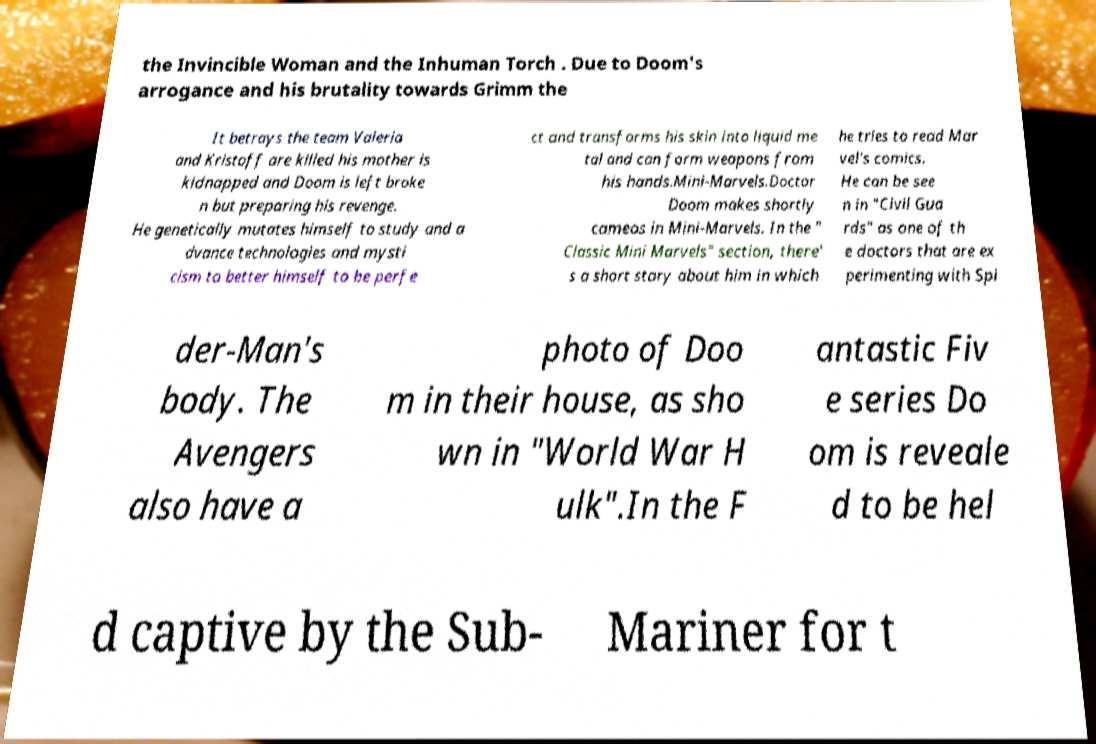Can you read and provide the text displayed in the image?This photo seems to have some interesting text. Can you extract and type it out for me? the Invincible Woman and the Inhuman Torch . Due to Doom's arrogance and his brutality towards Grimm the It betrays the team Valeria and Kristoff are killed his mother is kidnapped and Doom is left broke n but preparing his revenge. He genetically mutates himself to study and a dvance technologies and mysti cism to better himself to be perfe ct and transforms his skin into liquid me tal and can form weapons from his hands.Mini-Marvels.Doctor Doom makes shortly cameos in Mini-Marvels. In the " Classic Mini Marvels" section, there' s a short story about him in which he tries to read Mar vel's comics. He can be see n in "Civil Gua rds" as one of th e doctors that are ex perimenting with Spi der-Man's body. The Avengers also have a photo of Doo m in their house, as sho wn in "World War H ulk".In the F antastic Fiv e series Do om is reveale d to be hel d captive by the Sub- Mariner for t 